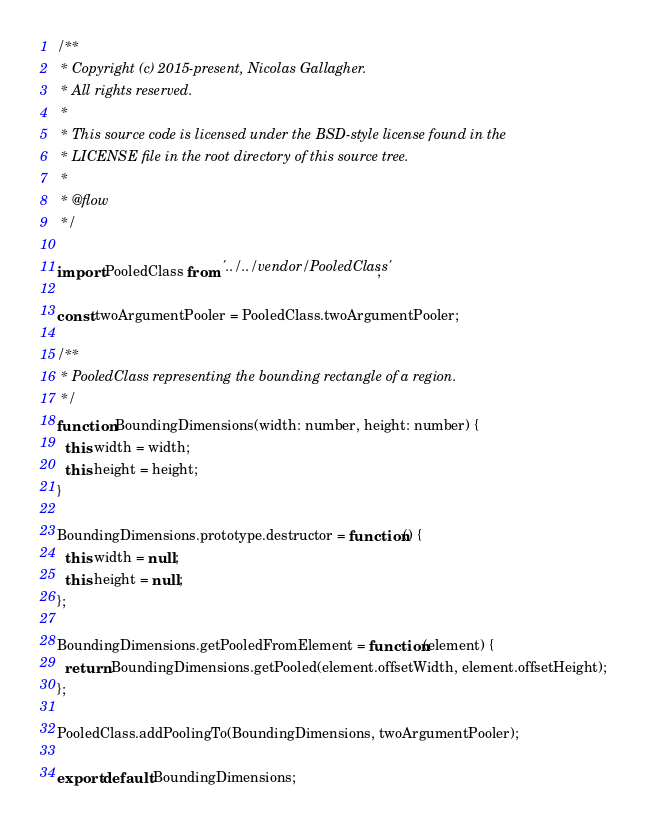<code> <loc_0><loc_0><loc_500><loc_500><_JavaScript_>/**
 * Copyright (c) 2015-present, Nicolas Gallagher.
 * All rights reserved.
 *
 * This source code is licensed under the BSD-style license found in the
 * LICENSE file in the root directory of this source tree.
 *
 * @flow
 */

import PooledClass from '../../vendor/PooledClass';

const twoArgumentPooler = PooledClass.twoArgumentPooler;

/**
 * PooledClass representing the bounding rectangle of a region.
 */
function BoundingDimensions(width: number, height: number) {
  this.width = width;
  this.height = height;
}

BoundingDimensions.prototype.destructor = function() {
  this.width = null;
  this.height = null;
};

BoundingDimensions.getPooledFromElement = function(element) {
  return BoundingDimensions.getPooled(element.offsetWidth, element.offsetHeight);
};

PooledClass.addPoolingTo(BoundingDimensions, twoArgumentPooler);

export default BoundingDimensions;
</code> 